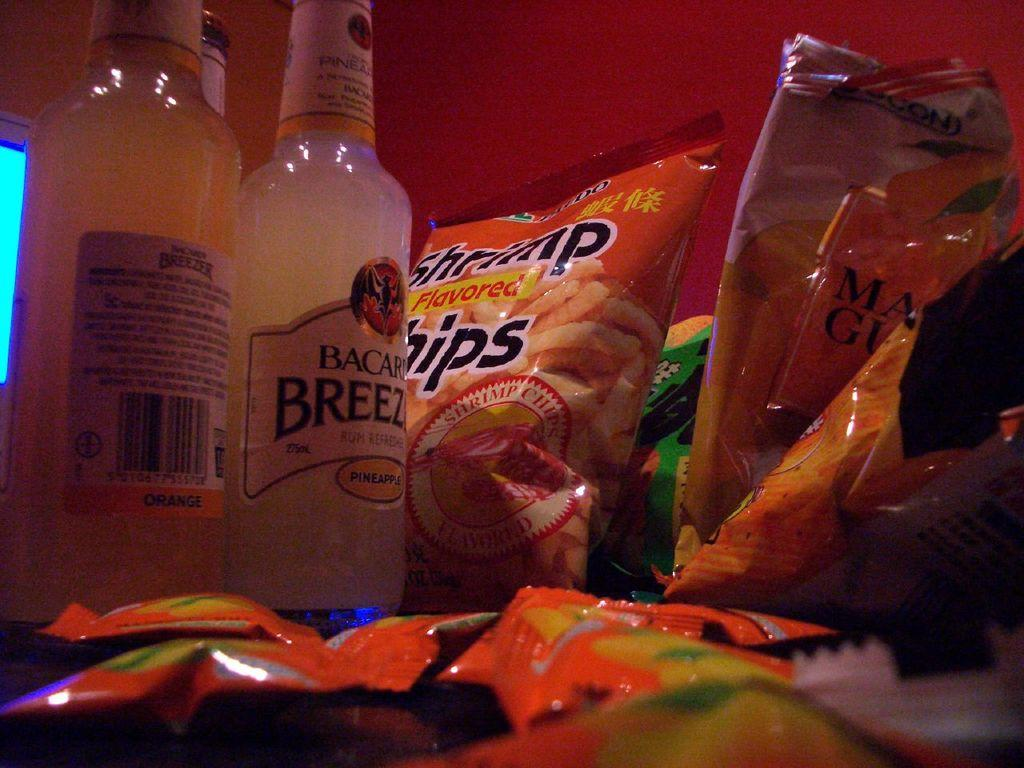<image>
Provide a brief description of the given image. A pile of snack foods are next to a bottle of Bacardi Breeze. 